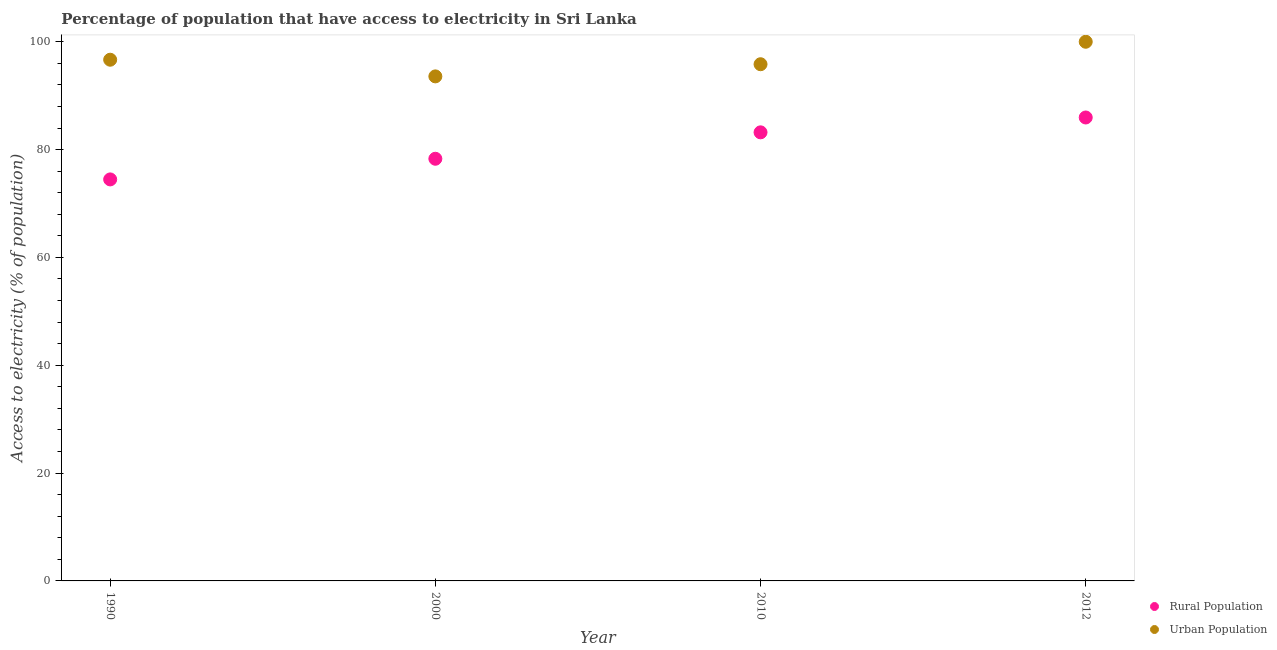How many different coloured dotlines are there?
Your response must be concise. 2. What is the percentage of rural population having access to electricity in 2010?
Your answer should be very brief. 83.2. Across all years, what is the maximum percentage of rural population having access to electricity?
Provide a short and direct response. 85.95. Across all years, what is the minimum percentage of rural population having access to electricity?
Offer a very short reply. 74.47. In which year was the percentage of rural population having access to electricity maximum?
Make the answer very short. 2012. What is the total percentage of urban population having access to electricity in the graph?
Provide a succinct answer. 386.08. What is the difference between the percentage of rural population having access to electricity in 2010 and that in 2012?
Give a very brief answer. -2.75. What is the difference between the percentage of rural population having access to electricity in 1990 and the percentage of urban population having access to electricity in 2012?
Your answer should be compact. -25.53. What is the average percentage of rural population having access to electricity per year?
Give a very brief answer. 80.48. In the year 2012, what is the difference between the percentage of urban population having access to electricity and percentage of rural population having access to electricity?
Give a very brief answer. 14.05. What is the ratio of the percentage of rural population having access to electricity in 1990 to that in 2012?
Your answer should be compact. 0.87. Is the percentage of rural population having access to electricity in 2000 less than that in 2012?
Keep it short and to the point. Yes. What is the difference between the highest and the second highest percentage of urban population having access to electricity?
Your answer should be very brief. 3.33. What is the difference between the highest and the lowest percentage of urban population having access to electricity?
Make the answer very short. 6.42. In how many years, is the percentage of urban population having access to electricity greater than the average percentage of urban population having access to electricity taken over all years?
Offer a very short reply. 2. Is the sum of the percentage of urban population having access to electricity in 1990 and 2010 greater than the maximum percentage of rural population having access to electricity across all years?
Provide a succinct answer. Yes. Does the percentage of rural population having access to electricity monotonically increase over the years?
Offer a very short reply. Yes. What is the difference between two consecutive major ticks on the Y-axis?
Your response must be concise. 20. Does the graph contain grids?
Provide a short and direct response. No. How are the legend labels stacked?
Give a very brief answer. Vertical. What is the title of the graph?
Provide a short and direct response. Percentage of population that have access to electricity in Sri Lanka. Does "Male entrants" appear as one of the legend labels in the graph?
Ensure brevity in your answer.  No. What is the label or title of the X-axis?
Give a very brief answer. Year. What is the label or title of the Y-axis?
Ensure brevity in your answer.  Access to electricity (% of population). What is the Access to electricity (% of population) in Rural Population in 1990?
Provide a succinct answer. 74.47. What is the Access to electricity (% of population) of Urban Population in 1990?
Provide a short and direct response. 96.67. What is the Access to electricity (% of population) in Rural Population in 2000?
Your response must be concise. 78.3. What is the Access to electricity (% of population) of Urban Population in 2000?
Keep it short and to the point. 93.58. What is the Access to electricity (% of population) in Rural Population in 2010?
Offer a terse response. 83.2. What is the Access to electricity (% of population) in Urban Population in 2010?
Your response must be concise. 95.83. What is the Access to electricity (% of population) in Rural Population in 2012?
Provide a succinct answer. 85.95. What is the Access to electricity (% of population) of Urban Population in 2012?
Offer a very short reply. 100. Across all years, what is the maximum Access to electricity (% of population) in Rural Population?
Your answer should be very brief. 85.95. Across all years, what is the minimum Access to electricity (% of population) in Rural Population?
Your response must be concise. 74.47. Across all years, what is the minimum Access to electricity (% of population) in Urban Population?
Your answer should be very brief. 93.58. What is the total Access to electricity (% of population) in Rural Population in the graph?
Your answer should be compact. 321.92. What is the total Access to electricity (% of population) in Urban Population in the graph?
Ensure brevity in your answer.  386.08. What is the difference between the Access to electricity (% of population) of Rural Population in 1990 and that in 2000?
Provide a short and direct response. -3.83. What is the difference between the Access to electricity (% of population) of Urban Population in 1990 and that in 2000?
Your answer should be compact. 3.09. What is the difference between the Access to electricity (% of population) of Rural Population in 1990 and that in 2010?
Offer a terse response. -8.73. What is the difference between the Access to electricity (% of population) of Urban Population in 1990 and that in 2010?
Give a very brief answer. 0.84. What is the difference between the Access to electricity (% of population) of Rural Population in 1990 and that in 2012?
Offer a very short reply. -11.48. What is the difference between the Access to electricity (% of population) of Urban Population in 1990 and that in 2012?
Provide a short and direct response. -3.33. What is the difference between the Access to electricity (% of population) of Urban Population in 2000 and that in 2010?
Keep it short and to the point. -2.25. What is the difference between the Access to electricity (% of population) in Rural Population in 2000 and that in 2012?
Keep it short and to the point. -7.65. What is the difference between the Access to electricity (% of population) of Urban Population in 2000 and that in 2012?
Provide a succinct answer. -6.42. What is the difference between the Access to electricity (% of population) in Rural Population in 2010 and that in 2012?
Ensure brevity in your answer.  -2.75. What is the difference between the Access to electricity (% of population) in Urban Population in 2010 and that in 2012?
Your answer should be very brief. -4.17. What is the difference between the Access to electricity (% of population) in Rural Population in 1990 and the Access to electricity (% of population) in Urban Population in 2000?
Your response must be concise. -19.11. What is the difference between the Access to electricity (% of population) in Rural Population in 1990 and the Access to electricity (% of population) in Urban Population in 2010?
Provide a short and direct response. -21.36. What is the difference between the Access to electricity (% of population) in Rural Population in 1990 and the Access to electricity (% of population) in Urban Population in 2012?
Make the answer very short. -25.53. What is the difference between the Access to electricity (% of population) of Rural Population in 2000 and the Access to electricity (% of population) of Urban Population in 2010?
Ensure brevity in your answer.  -17.53. What is the difference between the Access to electricity (% of population) in Rural Population in 2000 and the Access to electricity (% of population) in Urban Population in 2012?
Ensure brevity in your answer.  -21.7. What is the difference between the Access to electricity (% of population) of Rural Population in 2010 and the Access to electricity (% of population) of Urban Population in 2012?
Your answer should be very brief. -16.8. What is the average Access to electricity (% of population) in Rural Population per year?
Offer a very short reply. 80.48. What is the average Access to electricity (% of population) of Urban Population per year?
Provide a succinct answer. 96.52. In the year 1990, what is the difference between the Access to electricity (% of population) in Rural Population and Access to electricity (% of population) in Urban Population?
Provide a short and direct response. -22.2. In the year 2000, what is the difference between the Access to electricity (% of population) in Rural Population and Access to electricity (% of population) in Urban Population?
Offer a very short reply. -15.28. In the year 2010, what is the difference between the Access to electricity (% of population) of Rural Population and Access to electricity (% of population) of Urban Population?
Offer a terse response. -12.63. In the year 2012, what is the difference between the Access to electricity (% of population) of Rural Population and Access to electricity (% of population) of Urban Population?
Your answer should be compact. -14.05. What is the ratio of the Access to electricity (% of population) in Rural Population in 1990 to that in 2000?
Provide a succinct answer. 0.95. What is the ratio of the Access to electricity (% of population) in Urban Population in 1990 to that in 2000?
Your answer should be compact. 1.03. What is the ratio of the Access to electricity (% of population) of Rural Population in 1990 to that in 2010?
Provide a succinct answer. 0.9. What is the ratio of the Access to electricity (% of population) of Urban Population in 1990 to that in 2010?
Offer a terse response. 1.01. What is the ratio of the Access to electricity (% of population) of Rural Population in 1990 to that in 2012?
Provide a short and direct response. 0.87. What is the ratio of the Access to electricity (% of population) of Urban Population in 1990 to that in 2012?
Keep it short and to the point. 0.97. What is the ratio of the Access to electricity (% of population) of Rural Population in 2000 to that in 2010?
Your response must be concise. 0.94. What is the ratio of the Access to electricity (% of population) in Urban Population in 2000 to that in 2010?
Your answer should be compact. 0.98. What is the ratio of the Access to electricity (% of population) in Rural Population in 2000 to that in 2012?
Provide a succinct answer. 0.91. What is the ratio of the Access to electricity (% of population) in Urban Population in 2000 to that in 2012?
Your answer should be compact. 0.94. What is the ratio of the Access to electricity (% of population) of Rural Population in 2010 to that in 2012?
Provide a succinct answer. 0.97. What is the difference between the highest and the second highest Access to electricity (% of population) in Rural Population?
Provide a succinct answer. 2.75. What is the difference between the highest and the second highest Access to electricity (% of population) of Urban Population?
Your answer should be very brief. 3.33. What is the difference between the highest and the lowest Access to electricity (% of population) of Rural Population?
Your answer should be very brief. 11.48. What is the difference between the highest and the lowest Access to electricity (% of population) of Urban Population?
Your answer should be very brief. 6.42. 